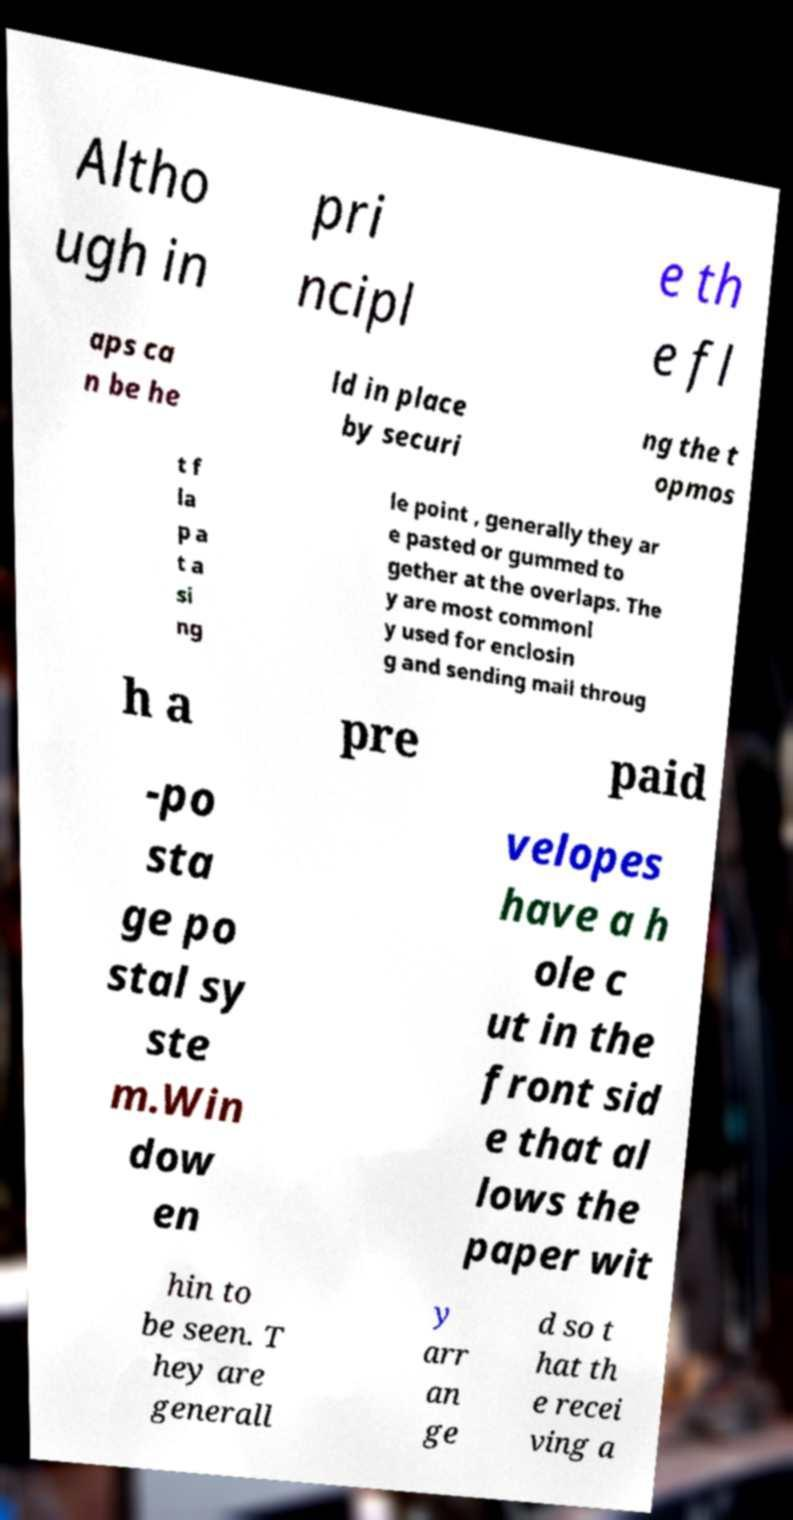Please read and relay the text visible in this image. What does it say? Altho ugh in pri ncipl e th e fl aps ca n be he ld in place by securi ng the t opmos t f la p a t a si ng le point , generally they ar e pasted or gummed to gether at the overlaps. The y are most commonl y used for enclosin g and sending mail throug h a pre paid -po sta ge po stal sy ste m.Win dow en velopes have a h ole c ut in the front sid e that al lows the paper wit hin to be seen. T hey are generall y arr an ge d so t hat th e recei ving a 